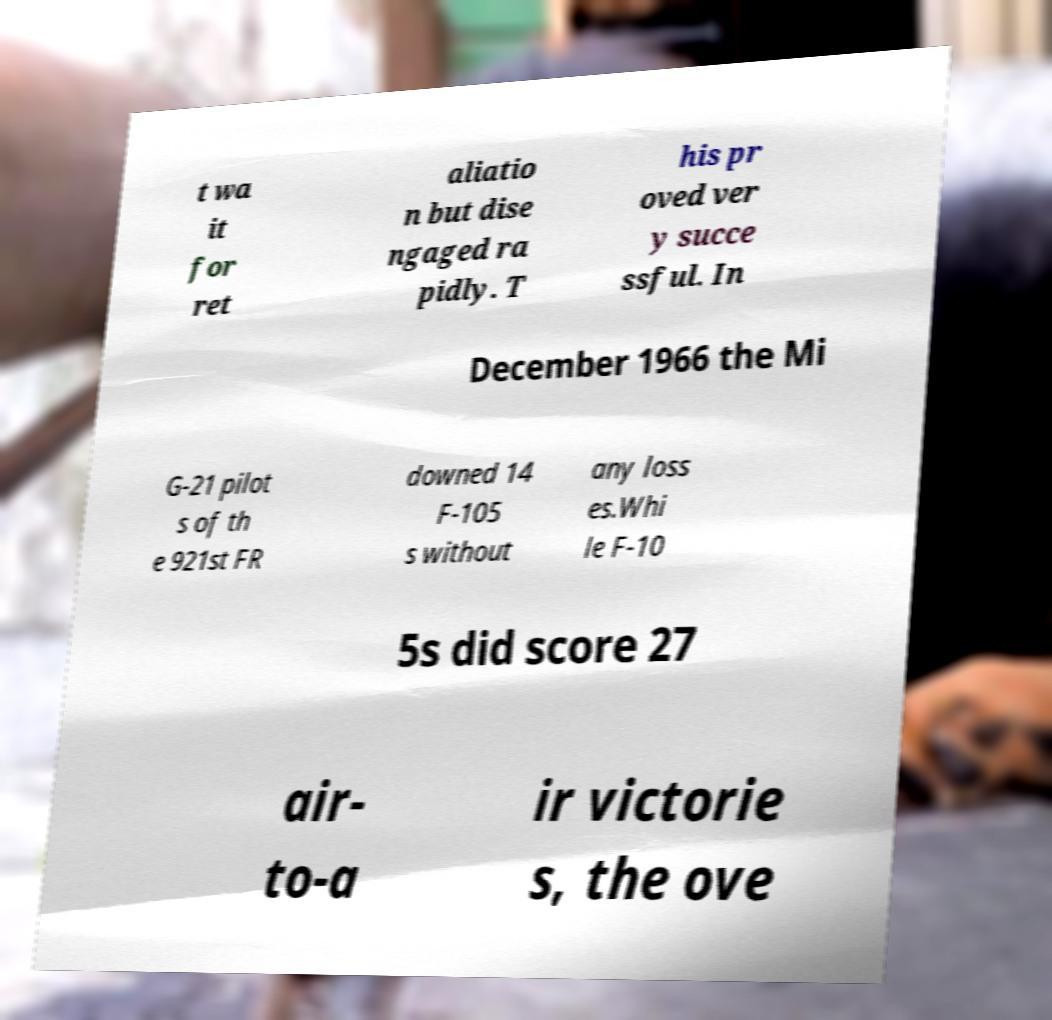What messages or text are displayed in this image? I need them in a readable, typed format. t wa it for ret aliatio n but dise ngaged ra pidly. T his pr oved ver y succe ssful. In December 1966 the Mi G-21 pilot s of th e 921st FR downed 14 F-105 s without any loss es.Whi le F-10 5s did score 27 air- to-a ir victorie s, the ove 